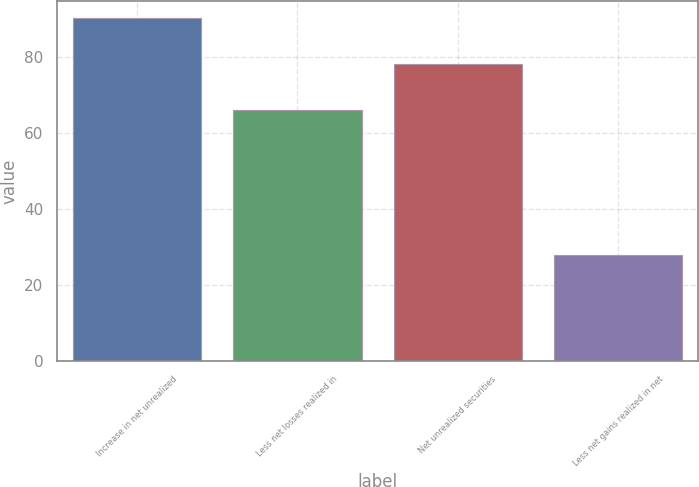<chart> <loc_0><loc_0><loc_500><loc_500><bar_chart><fcel>Increase in net unrealized<fcel>Less net losses realized in<fcel>Net unrealized securities<fcel>Less net gains realized in net<nl><fcel>90.2<fcel>66<fcel>78.1<fcel>28<nl></chart> 